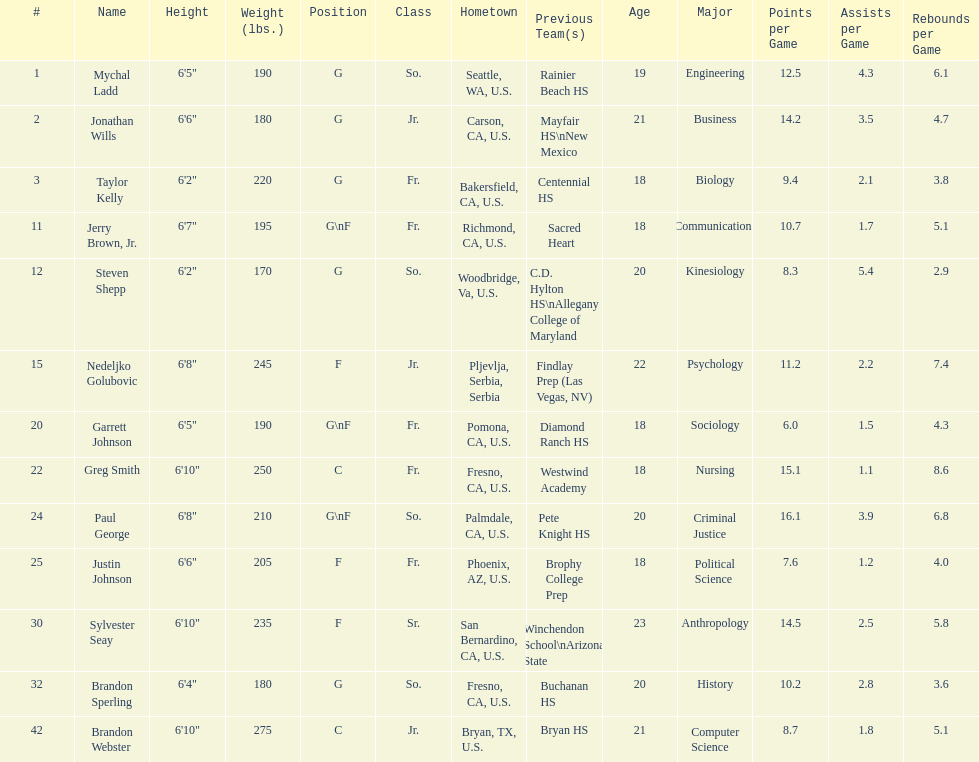Taylor kelly is shorter than 6' 3", which other player is also shorter than 6' 3"? Steven Shepp. 